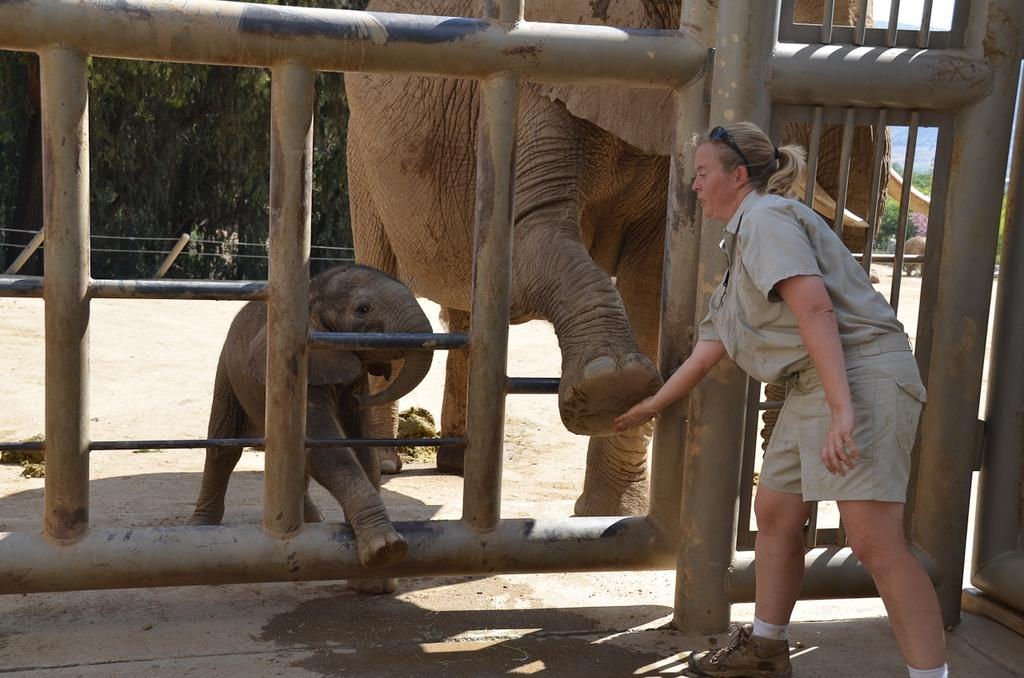What animals are present in the image? There are elephants in the image. What is the woman in the image doing? The woman is touching the foot of an elephant. What type of terrain can be seen in the background of the image? There is sand in the background of the image. What structures are visible in the background of the image? There is a wooden grill and poles in the background of the image. What type of vegetation is present in the background of the image? There are trees in the background of the image. What is visible in the sky in the background of the image? The sky is visible in the background of the image. What type of prose is being recited by the elephants in the image? There is no indication in the image that the elephants are reciting any prose. 